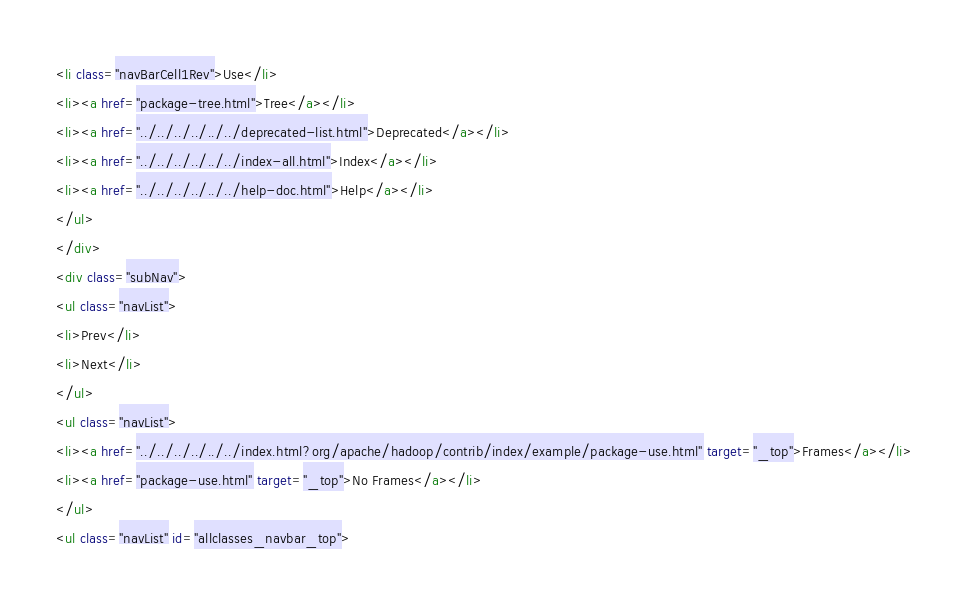Convert code to text. <code><loc_0><loc_0><loc_500><loc_500><_HTML_><li class="navBarCell1Rev">Use</li>
<li><a href="package-tree.html">Tree</a></li>
<li><a href="../../../../../../deprecated-list.html">Deprecated</a></li>
<li><a href="../../../../../../index-all.html">Index</a></li>
<li><a href="../../../../../../help-doc.html">Help</a></li>
</ul>
</div>
<div class="subNav">
<ul class="navList">
<li>Prev</li>
<li>Next</li>
</ul>
<ul class="navList">
<li><a href="../../../../../../index.html?org/apache/hadoop/contrib/index/example/package-use.html" target="_top">Frames</a></li>
<li><a href="package-use.html" target="_top">No Frames</a></li>
</ul>
<ul class="navList" id="allclasses_navbar_top"></code> 